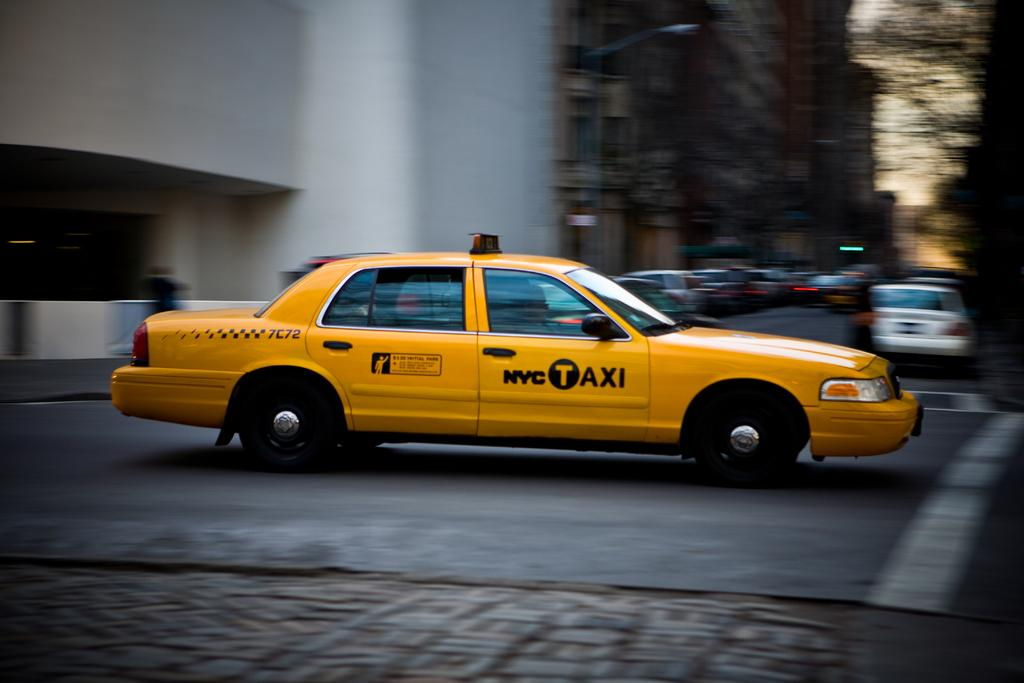Provide a one-sentence caption for the provided image. A bright yellow NYC Taxi speeds through an intersection. 